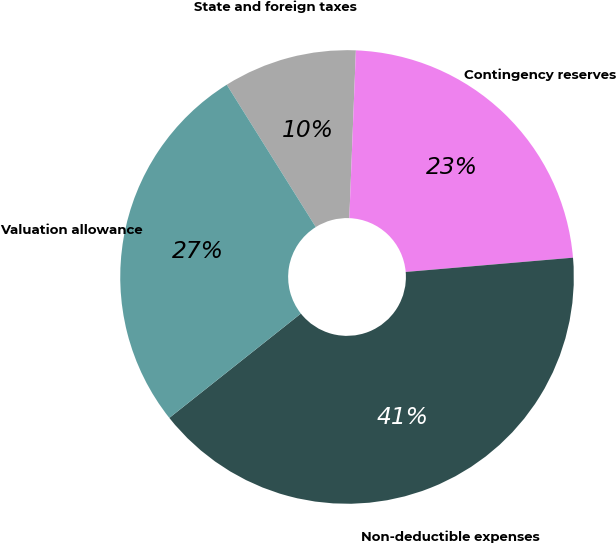Convert chart. <chart><loc_0><loc_0><loc_500><loc_500><pie_chart><fcel>State and foreign taxes<fcel>Contingency reserves<fcel>Non-deductible expenses<fcel>Valuation allowance<nl><fcel>9.52%<fcel>23.02%<fcel>40.68%<fcel>26.77%<nl></chart> 